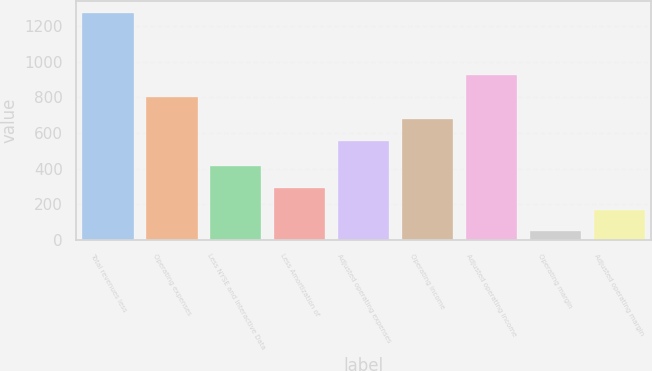Convert chart to OTSL. <chart><loc_0><loc_0><loc_500><loc_500><bar_chart><fcel>Total revenues less<fcel>Operating expenses<fcel>Less NYSE and Interactive Data<fcel>Less Amortization of<fcel>Adjusted operating expenses<fcel>Operating income<fcel>Adjusted operating income<fcel>Operating margin<fcel>Adjusted operating margin<nl><fcel>1276<fcel>801.8<fcel>415.7<fcel>292.8<fcel>556<fcel>678.9<fcel>924.7<fcel>47<fcel>169.9<nl></chart> 